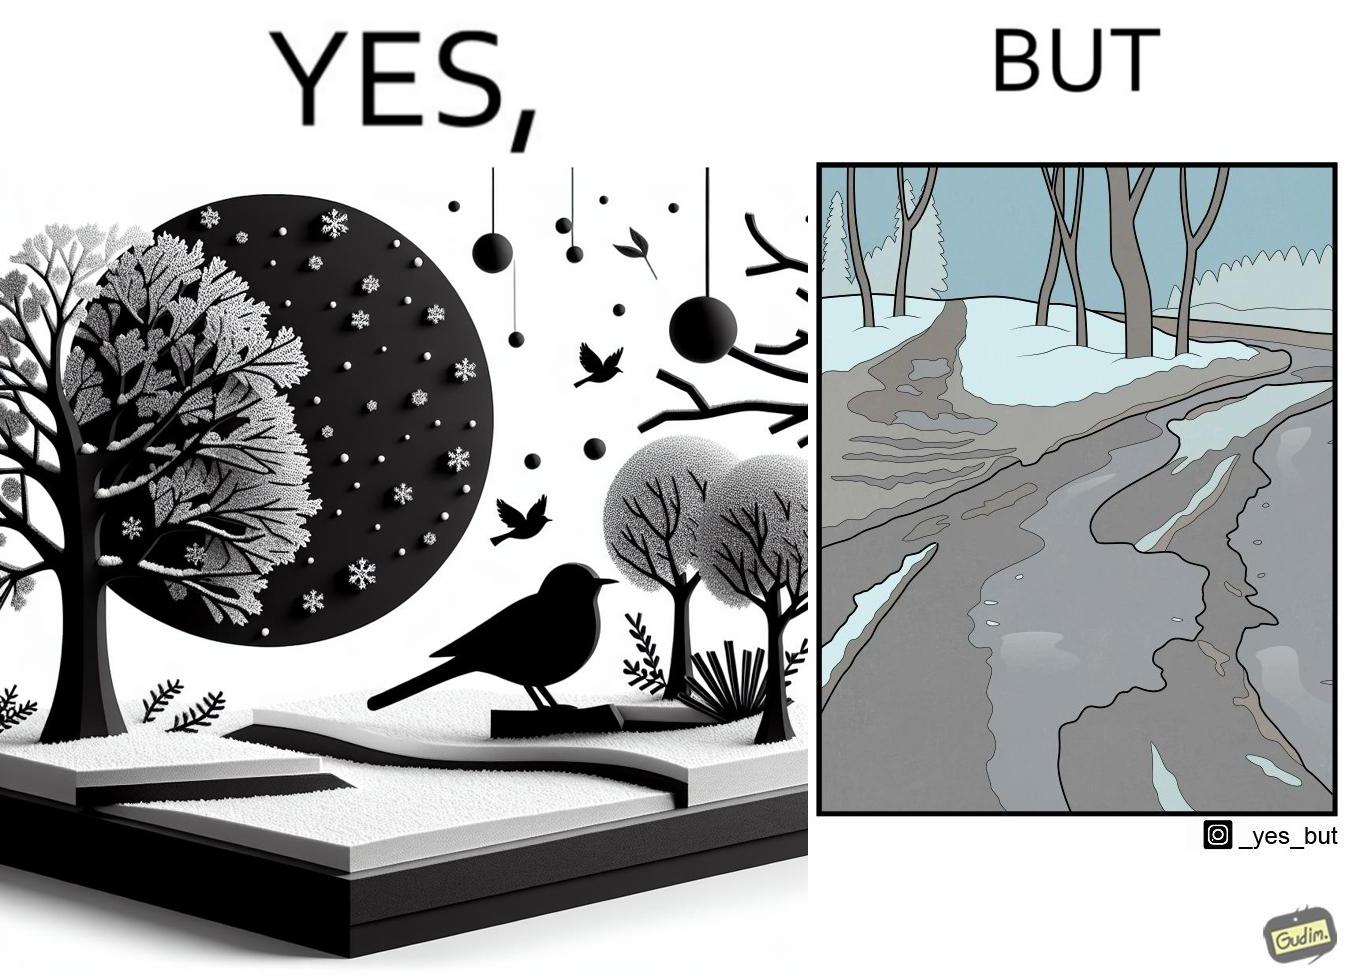Is this image satirical or non-satirical? Yes, this image is satirical. 